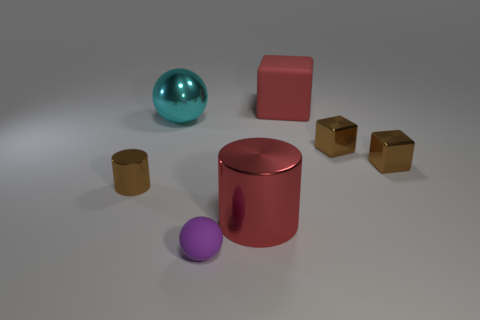Subtract all yellow cylinders. How many brown blocks are left? 2 Subtract 1 cubes. How many cubes are left? 2 Add 2 small purple spheres. How many objects exist? 9 Subtract all large cylinders. Subtract all tiny brown shiny things. How many objects are left? 3 Add 1 tiny spheres. How many tiny spheres are left? 2 Add 5 tiny red matte cubes. How many tiny red matte cubes exist? 5 Subtract 1 brown cylinders. How many objects are left? 6 Subtract all balls. How many objects are left? 5 